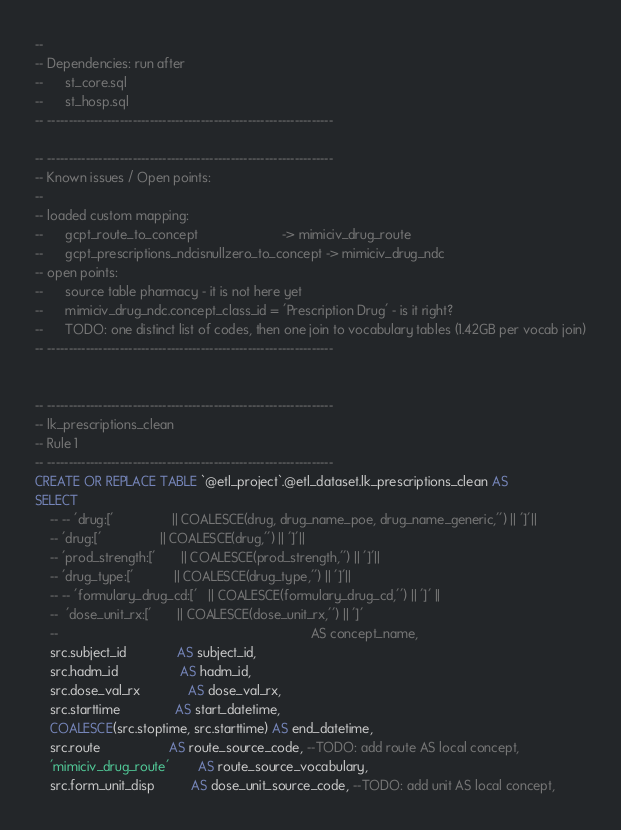<code> <loc_0><loc_0><loc_500><loc_500><_SQL_>-- 
-- Dependencies: run after 
--      st_core.sql
--      st_hosp.sql
-- -------------------------------------------------------------------

-- -------------------------------------------------------------------
-- Known issues / Open points:
--
-- loaded custom mapping:
--      gcpt_route_to_concept                       -> mimiciv_drug_route
--      gcpt_prescriptions_ndcisnullzero_to_concept -> mimiciv_drug_ndc
-- open points: 
--      source table pharmacy - it is not here yet
--      mimiciv_drug_ndc.concept_class_id = 'Prescription Drug' - is it right?
--      TODO: one distinct list of codes, then one join to vocabulary tables (1.42GB per vocab join)
-- -------------------------------------------------------------------


-- -------------------------------------------------------------------
-- lk_prescriptions_clean 
-- Rule 1
-- -------------------------------------------------------------------
CREATE OR REPLACE TABLE `@etl_project`.@etl_dataset.lk_prescriptions_clean AS
SELECT
    -- -- 'drug:['                || COALESCE(drug, drug_name_poe, drug_name_generic,'') || ']'||
    -- 'drug:['                || COALESCE(drug,'') || ']'||
    -- 'prod_strength:['       || COALESCE(prod_strength,'') || ']'||
    -- 'drug_type:['           || COALESCE(drug_type,'') || ']'||
    -- -- 'formulary_drug_cd:['   || COALESCE(formulary_drug_cd,'') || ']' ||
    --  'dose_unit_rx:['       || COALESCE(dose_unit_rx,'') || ']' 
    --                                                                     AS concept_name,
    src.subject_id              AS subject_id,
    src.hadm_id                 AS hadm_id,
    src.dose_val_rx             AS dose_val_rx,
    src.starttime               AS start_datetime,
    COALESCE(src.stoptime, src.starttime) AS end_datetime,
    src.route                   AS route_source_code, --TODO: add route AS local concept,
    'mimiciv_drug_route'        AS route_source_vocabulary,
    src.form_unit_disp          AS dose_unit_source_code, --TODO: add unit AS local concept,</code> 